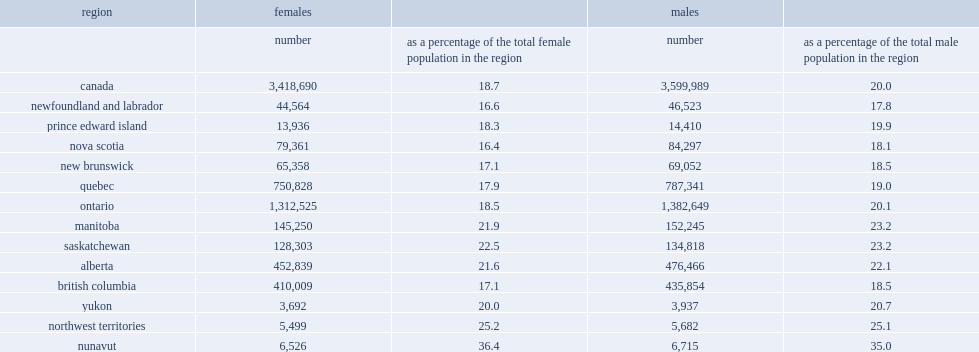What is the percentage of canada's female population is girl on july 1,2016? 18.7. What is the percentage of girls aged 17 and under in nunavut? 36.4. What is the percentage of girls aged 17 and under in nova scotia? 16.4. 